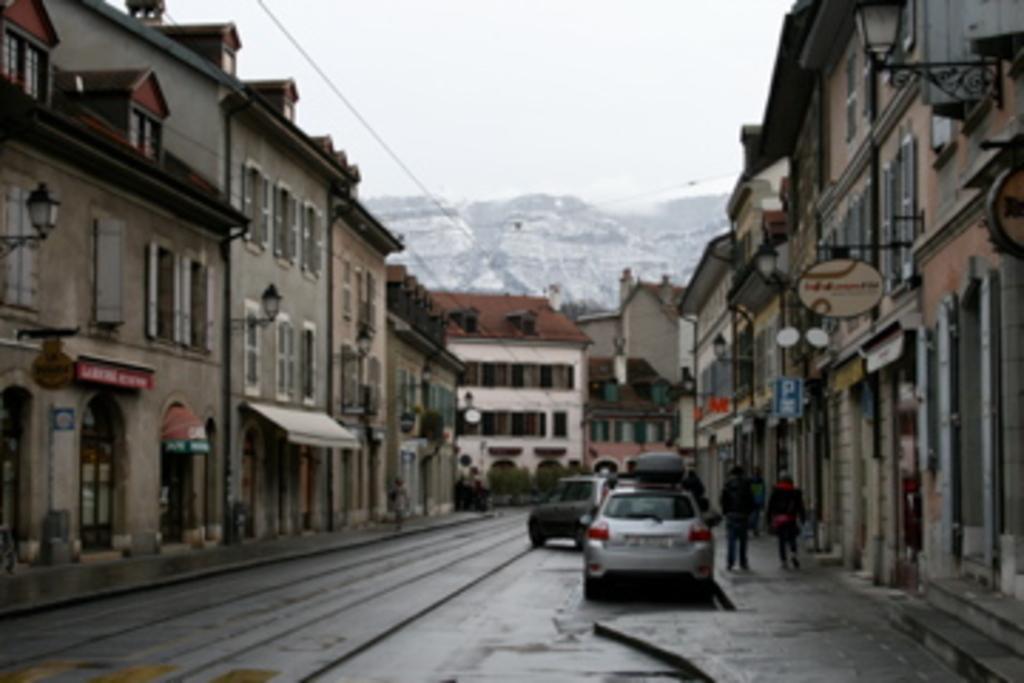How would you summarize this image in a sentence or two? Vehicles are on the road. In this image we can see buildings, people, boards and plants. Background we can see the sky.  